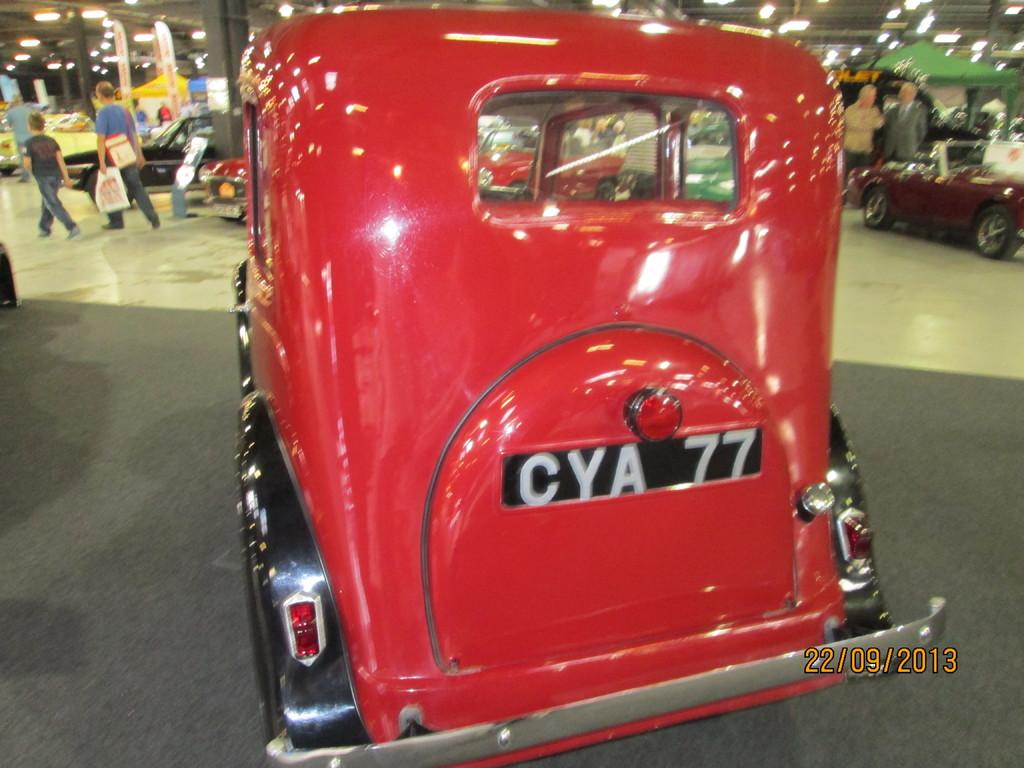What is the color of the car in the foreground of the image? The car in the foreground of the image is red. What can be seen in the background of the image? There are many people and parked cars in the background of the image. What type of lighting is present in the image? There are lights in the ceiling of the image. Can you tell me how many beads are hanging from the horse in the image? There is no horse or beads present in the image. What type of cellar can be seen in the image? There is no cellar present in the image. 